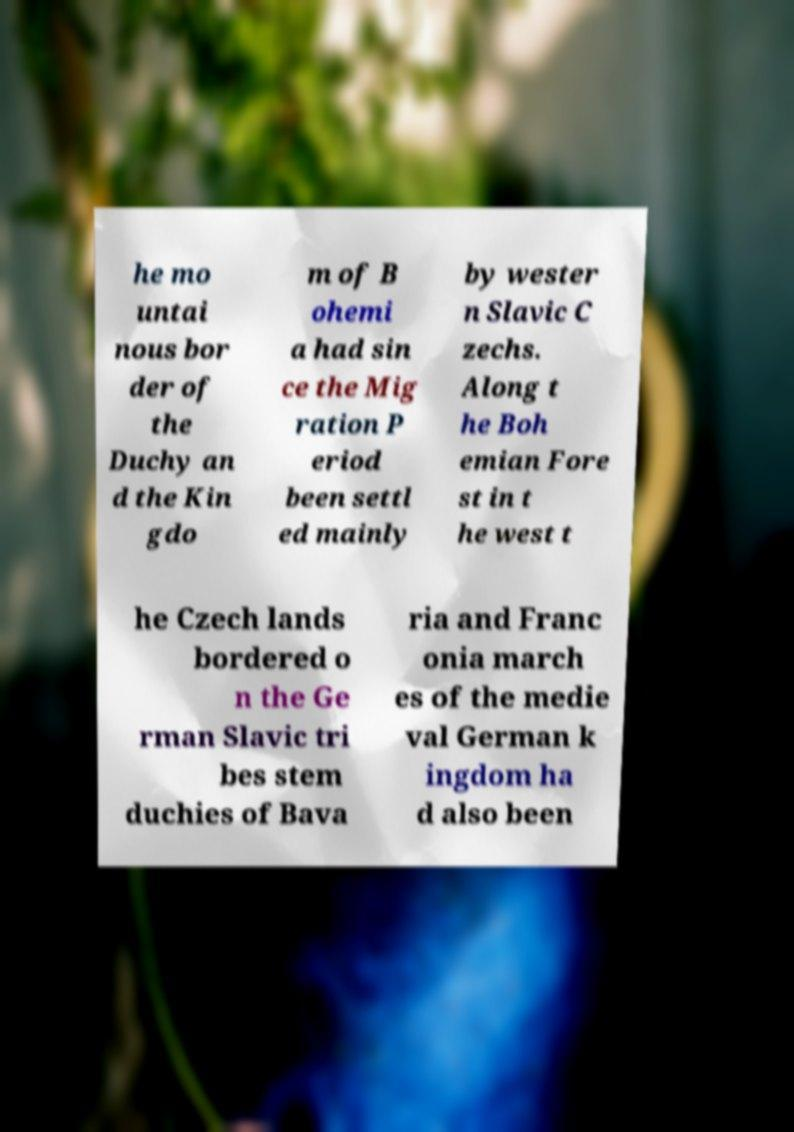Could you assist in decoding the text presented in this image and type it out clearly? he mo untai nous bor der of the Duchy an d the Kin gdo m of B ohemi a had sin ce the Mig ration P eriod been settl ed mainly by wester n Slavic C zechs. Along t he Boh emian Fore st in t he west t he Czech lands bordered o n the Ge rman Slavic tri bes stem duchies of Bava ria and Franc onia march es of the medie val German k ingdom ha d also been 